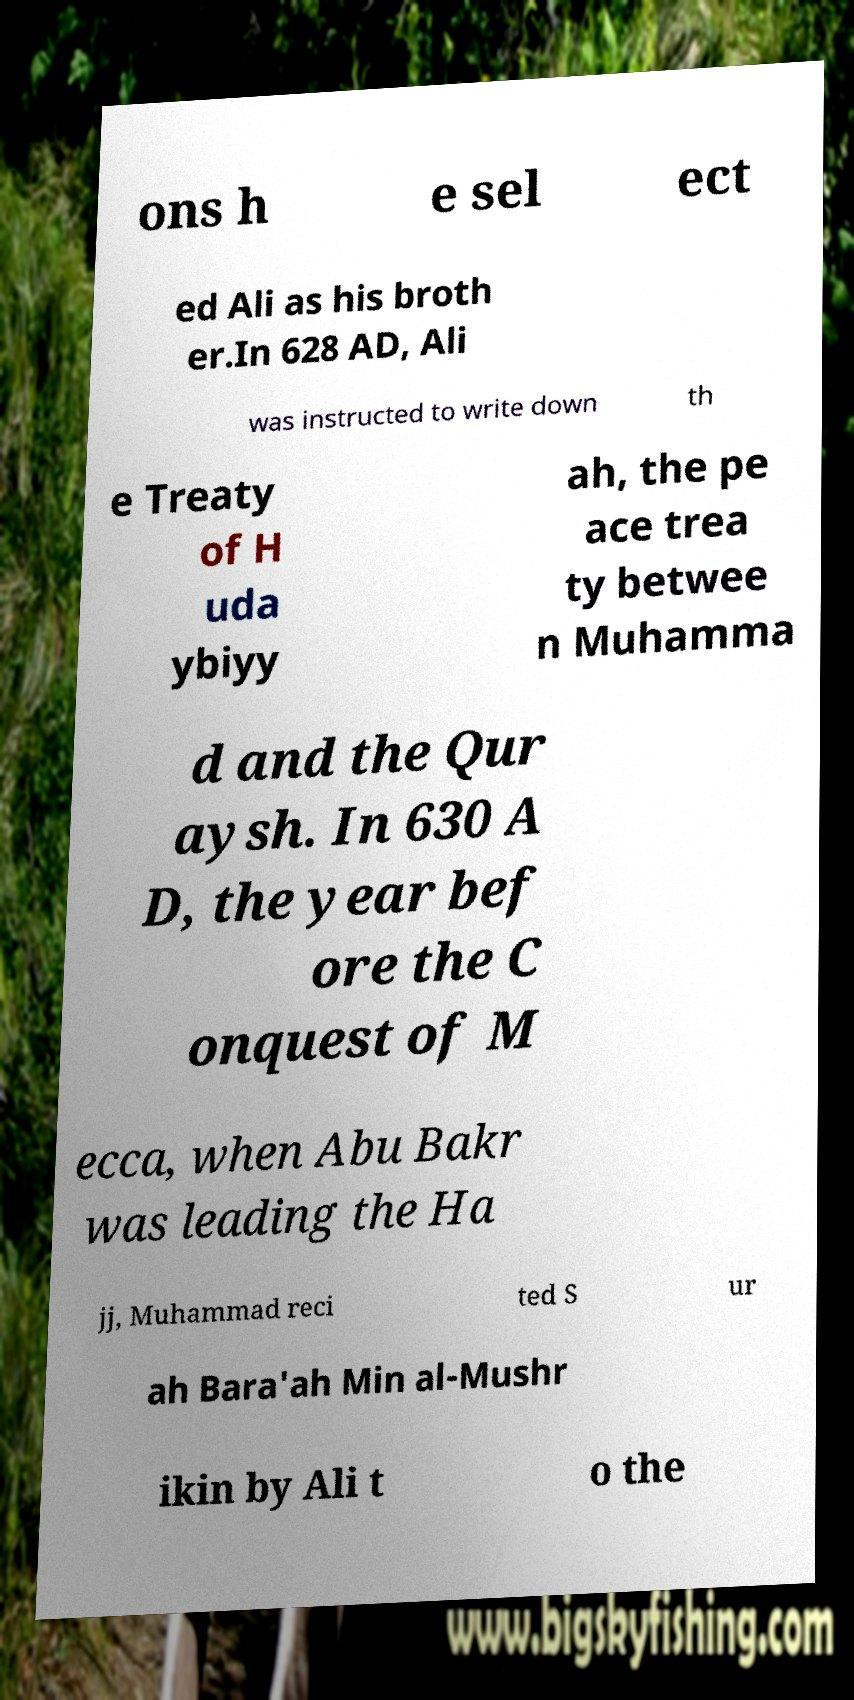Could you assist in decoding the text presented in this image and type it out clearly? ons h e sel ect ed Ali as his broth er.In 628 AD, Ali was instructed to write down th e Treaty of H uda ybiyy ah, the pe ace trea ty betwee n Muhamma d and the Qur aysh. In 630 A D, the year bef ore the C onquest of M ecca, when Abu Bakr was leading the Ha jj, Muhammad reci ted S ur ah Bara'ah Min al-Mushr ikin by Ali t o the 